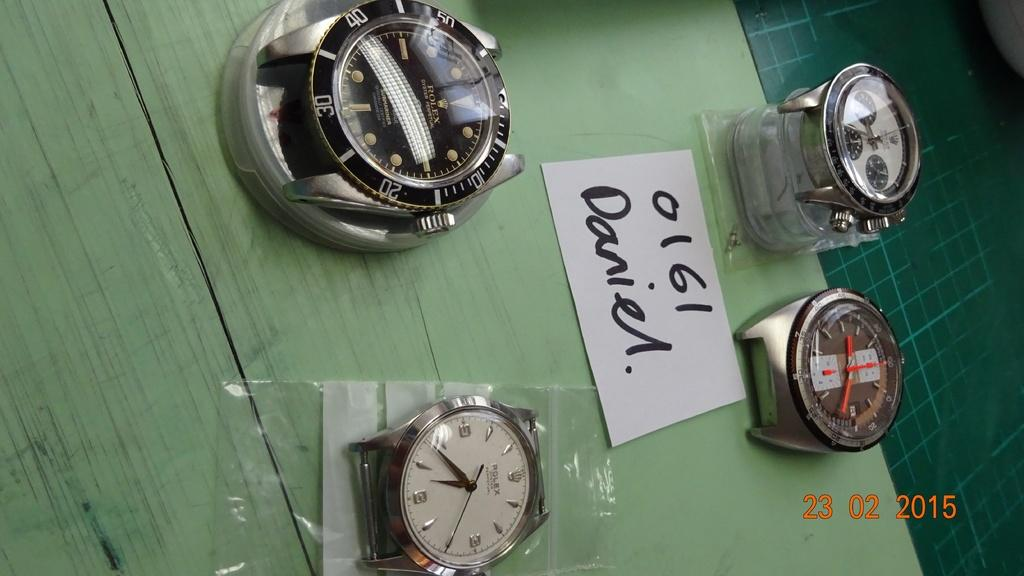<image>
Create a compact narrative representing the image presented. A photo of strapless watches from February 23 2015. 